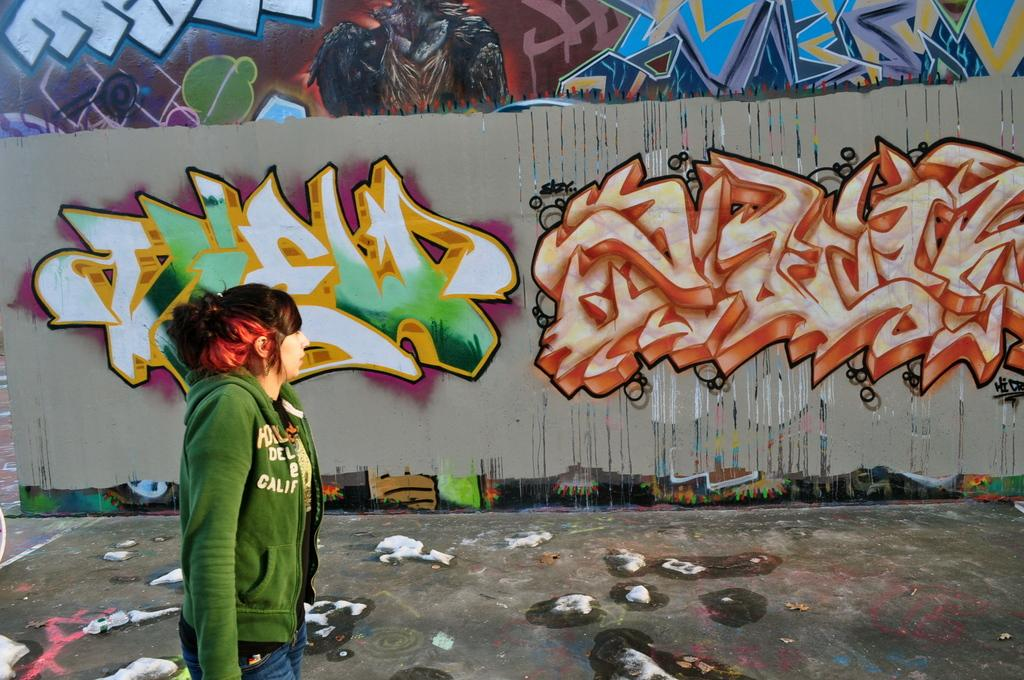Who is present in the image? There is a lady in the image. What can be seen in the background of the image? There is graffiti on a wall in the background of the image. What object is located at the bottom of the image? There is a bottle at the bottom of the image. What else can be seen on the road in the image? There are other objects on the road in the image. How does the graffiti contribute to the growth of the plants in the image? There are no plants present in the image, so the graffiti does not contribute to their growth. 